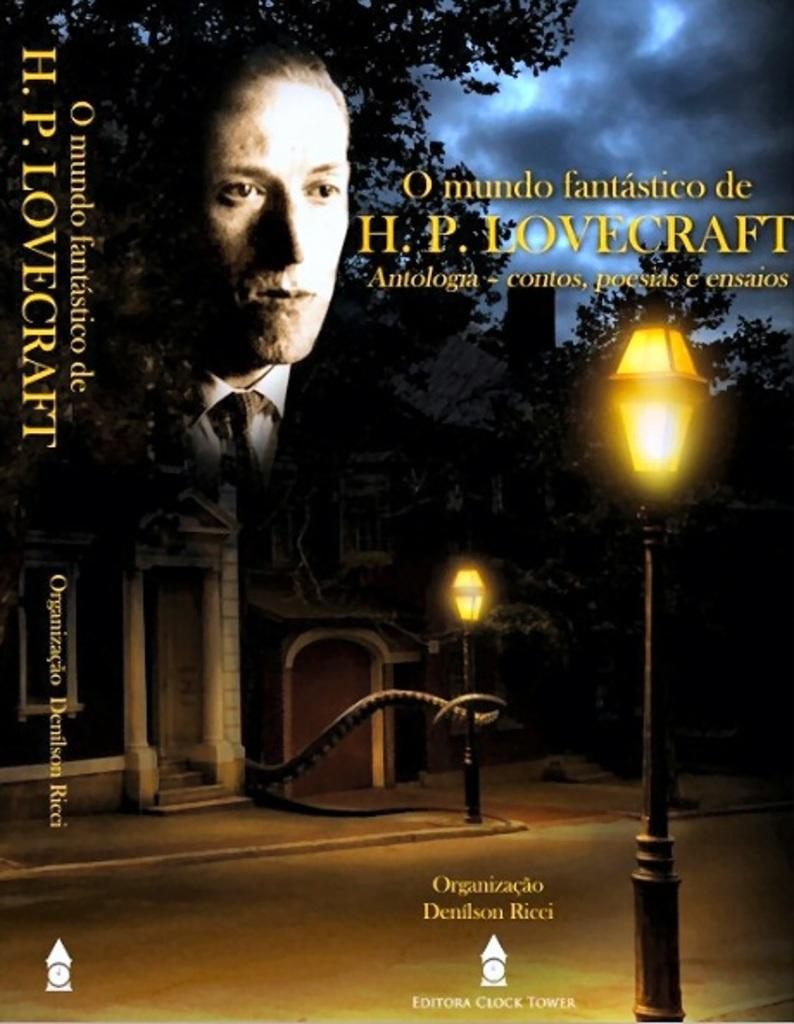<image>
Write a terse but informative summary of the picture. A poster for a show with the face of H.P. Lovecraft overlaying a house. 